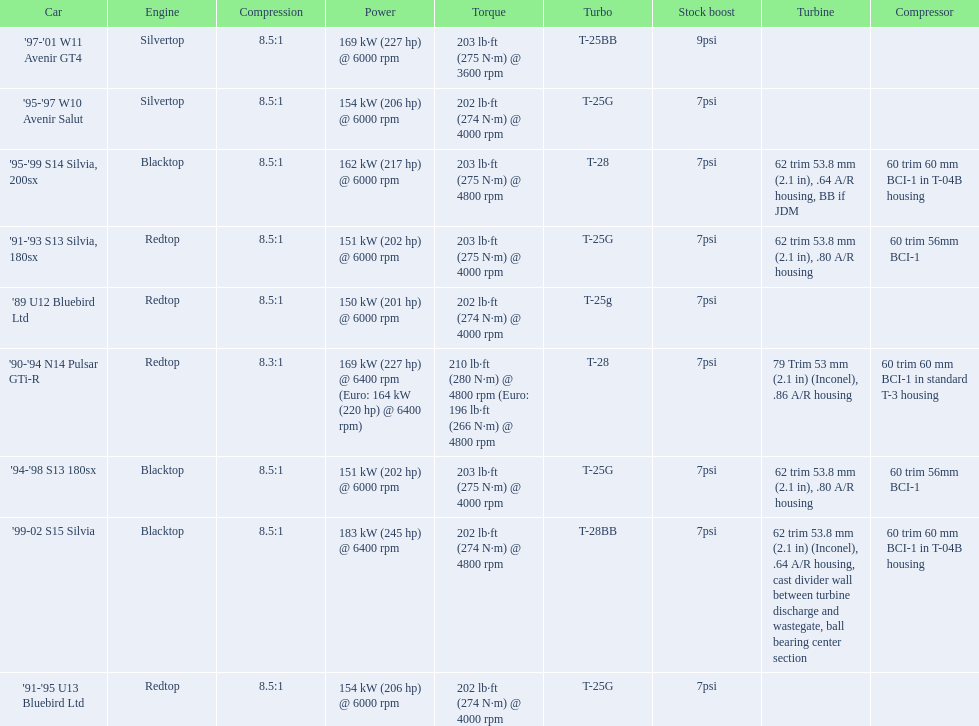What are all of the cars? '89 U12 Bluebird Ltd, '91-'95 U13 Bluebird Ltd, '95-'97 W10 Avenir Salut, '97-'01 W11 Avenir GT4, '90-'94 N14 Pulsar GTi-R, '91-'93 S13 Silvia, 180sx, '94-'98 S13 180sx, '95-'99 S14 Silvia, 200sx, '99-02 S15 Silvia. What is their rated power? 150 kW (201 hp) @ 6000 rpm, 154 kW (206 hp) @ 6000 rpm, 154 kW (206 hp) @ 6000 rpm, 169 kW (227 hp) @ 6000 rpm, 169 kW (227 hp) @ 6400 rpm (Euro: 164 kW (220 hp) @ 6400 rpm), 151 kW (202 hp) @ 6000 rpm, 151 kW (202 hp) @ 6000 rpm, 162 kW (217 hp) @ 6000 rpm, 183 kW (245 hp) @ 6400 rpm. Which car has the most power? '99-02 S15 Silvia. 